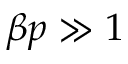<formula> <loc_0><loc_0><loc_500><loc_500>\beta p \gg 1</formula> 